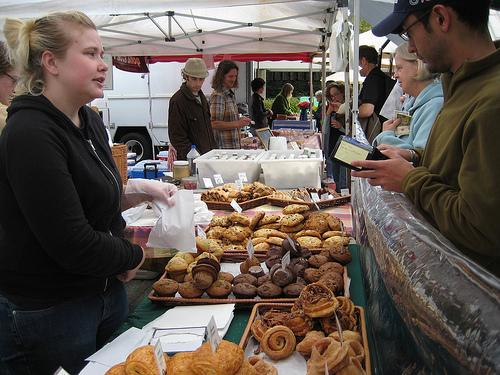Provide a description of the counter covered in polythene. The counter covered in polythene is a display area for pastries, muffins, and other baked goods, and it is protected by a transparent plastic cover. Count the number of cookies and muffins in the image. There are two cookies and four muffins in the image. Identify the type of food being sold in the image. Pastries, muffins, and donuts are being sold in the image. Mention the activity the man in the hat is involved in. The man in the hat is buying food. What is the color of the jacket worn by the man? The jacket worn by the man is black in color. State the type of sign found in the image and its color. There is a white posted sign in the image for pastries. Analyze the sentiment communicated by the image. The image conveys a positive sentiment of people enjoying and purchasing baked goods. Describe the appearance of the wallet being opened by the man. The wallet being opened by the man is brown and made of leather. What is the woman in the hooded sweatshirt doing? The woman in the hooded sweatshirt is serving baked goods. Which objects in the image interact with each other and what is their interaction? Woman and pastries; woman is selling the pastries What are the objects that are being sold in the image? Pastries, muffins, donuts, and cookies Find the stack of newspapers at the corner of the image. No, it's not mentioned in the image. Using the given image, label each object within their respective boundaries. Insert semantic segmentation labels for all objects in the image What type of food is being sold in the given image? Baked goods Find the object that matches the description "a delicious donut for sale" and provide its coordinates and size. X:297 Y:283 Width:40 Height:40 Identify the objects in the image that are for sale. Muffins, donuts, and cookies State the relation between the woman serving baked goods and the pastries being sold. The woman is selling the pastries. Identify the captions that refer to the same object as "a chocolate muffin in a tray". "muffin freshly baked and ready for sale", "chocolate muffin next to other muffins" What are the captions that mention color in the image? "snacks are brown in color", "the price tags are white in color", "jacket is black in color", "tray is white in color", "the seater is dull blue in color" What are the attributes of the jacket and hat worn by a man in the image? Jacket: black; Hat: worn What is the sentiment of the image with a woman serving baked goods? Positive What is the text on the white posted sign in the image? Unable to determine, no text provided. Does the woman in the image wear a glove and what color is it? Yes, she wears a glove, but the color is not mentioned. Is the quality of the image containing baked goods good or bad? Good How many kinds of baked goods are available for purchase in the image? Muffins, donuts, and cookies (3 kinds) What is the position and size of the wallet being opened by a man and the container of some goods? Wallet: X:330 Y:133 Width:70 Height:70; Container: X:190 Y:148 Width:72 Height:72 Describe the emotion and quality of the image with baked goods. The image has a positive emotion and good quality. Which object is more likely to be in "snacks are brown in color": freshly baked cookie or white posted sign? Freshly baked cookie Are there any strange or unexpected objects in the image with pastries? No, all objects are expected in the context of pastries. What are the colors mentioned in the image captions? White, black, brown, and dull blue 